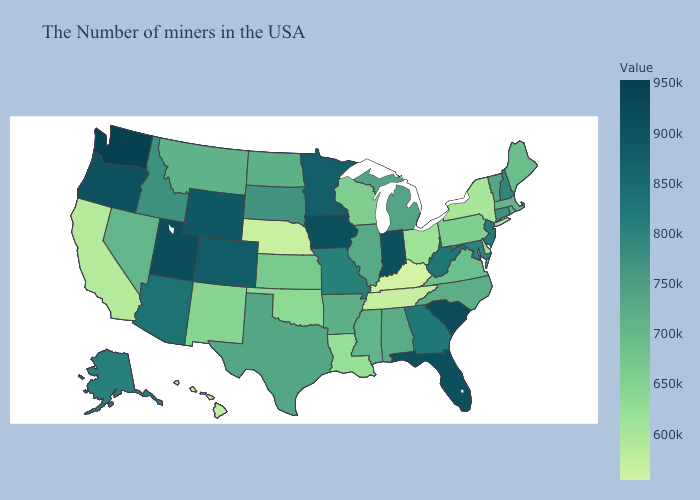Which states have the highest value in the USA?
Give a very brief answer. Washington. Does Maine have the lowest value in the Northeast?
Be succinct. No. Does New Mexico have a lower value than Hawaii?
Write a very short answer. No. 